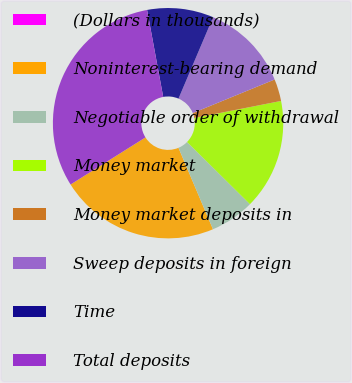Convert chart to OTSL. <chart><loc_0><loc_0><loc_500><loc_500><pie_chart><fcel>(Dollars in thousands)<fcel>Noninterest-bearing demand<fcel>Negotiable order of withdrawal<fcel>Money market<fcel>Money market deposits in<fcel>Sweep deposits in foreign<fcel>Time<fcel>Total deposits<nl><fcel>0.0%<fcel>22.44%<fcel>6.21%<fcel>15.51%<fcel>3.1%<fcel>12.41%<fcel>9.31%<fcel>31.02%<nl></chart> 